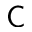<formula> <loc_0><loc_0><loc_500><loc_500>C</formula> 